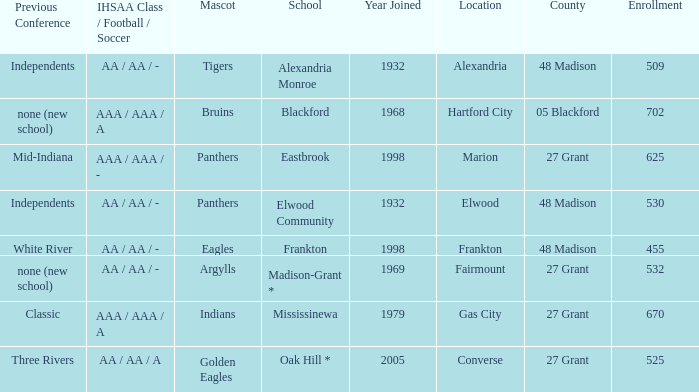What is the previous conference when the location is converse? Three Rivers. 